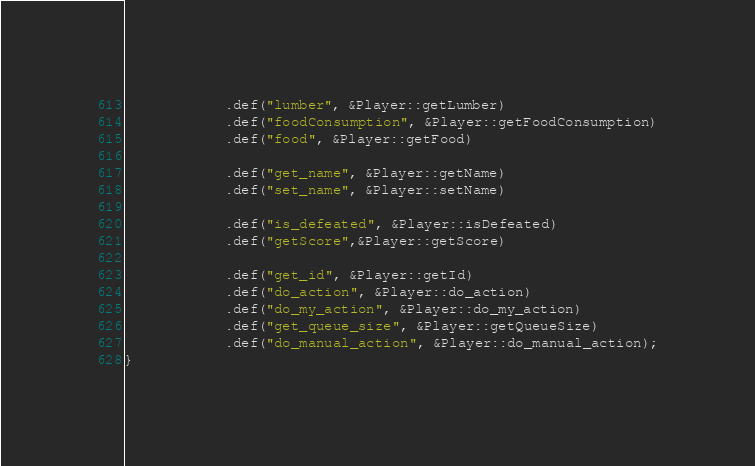<code> <loc_0><loc_0><loc_500><loc_500><_C++_>            .def("lumber", &Player::getLumber)
            .def("foodConsumption", &Player::getFoodConsumption)
            .def("food", &Player::getFood)

            .def("get_name", &Player::getName)
            .def("set_name", &Player::setName)

            .def("is_defeated", &Player::isDefeated)
            .def("getScore",&Player::getScore)

            .def("get_id", &Player::getId)
            .def("do_action", &Player::do_action)
            .def("do_my_action", &Player::do_my_action)
            .def("get_queue_size", &Player::getQueueSize)
            .def("do_manual_action", &Player::do_manual_action);
}</code> 